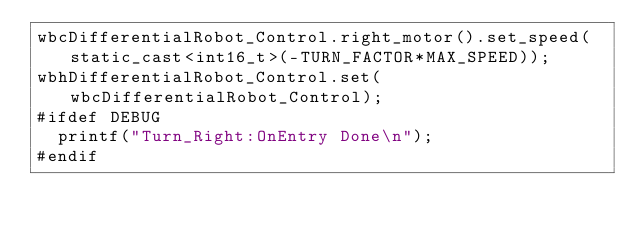<code> <loc_0><loc_0><loc_500><loc_500><_ObjectiveC_>wbcDifferentialRobot_Control.right_motor().set_speed(static_cast<int16_t>(-TURN_FACTOR*MAX_SPEED));
wbhDifferentialRobot_Control.set(wbcDifferentialRobot_Control);
#ifdef DEBUG
  printf("Turn_Right:OnEntry Done\n");
#endif
</code> 